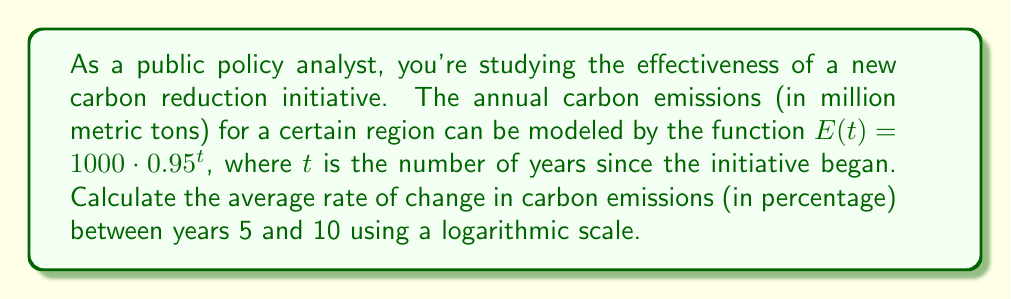Help me with this question. Let's approach this step-by-step:

1) First, we need to calculate the emissions at years 5 and 10:

   $E(5) = 1000 \cdot 0.95^5 = 773.78$ million metric tons
   $E(10) = 1000 \cdot 0.95^{10} = 598.74$ million metric tons

2) To use a logarithmic scale, we'll take the natural log of these values:

   $\ln(E(5)) = \ln(773.78) = 6.6513$
   $\ln(E(10)) = \ln(598.74) = 6.3948$

3) The rate of change on a logarithmic scale is calculated as the difference in log values divided by the time interval:

   Rate of change = $\frac{\ln(E(10)) - \ln(E(5))}{10 - 5} = \frac{6.3948 - 6.6513}{5} = -0.0513$ per year

4) To express this as a percentage, we multiply by 100:

   Percentage rate of change = $-0.0513 \cdot 100 = -5.13\%$ per year

5) The negative sign indicates that emissions are decreasing over time.

This logarithmic approach gives us the average percentage change per year, which is useful for analyzing exponential decay processes like the one in this emissions model.
Answer: $-5.13\%$ per year 